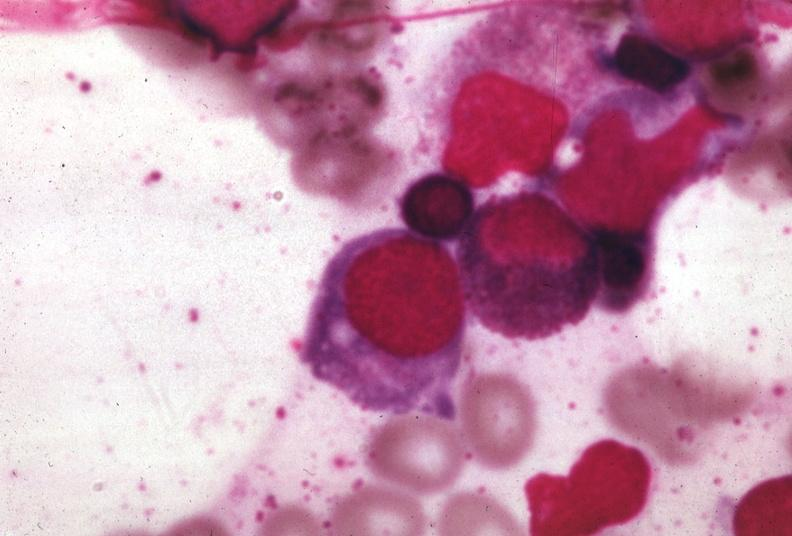s hematologic present?
Answer the question using a single word or phrase. Yes 